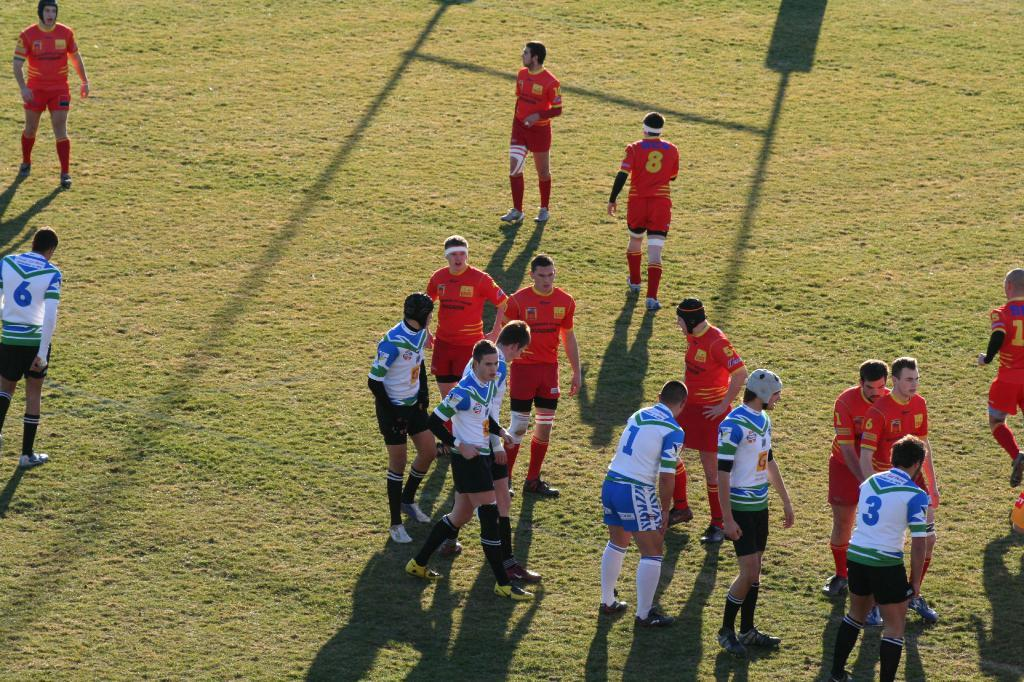Who or what is present in the image? There are people in the image. What are the people wearing? The people are wearing uniforms. Where are the people located in the image? The people are standing on the ground. What type of guide can be seen in the image? There is no guide present in the image; it only features people wearing uniforms and standing on the ground. 